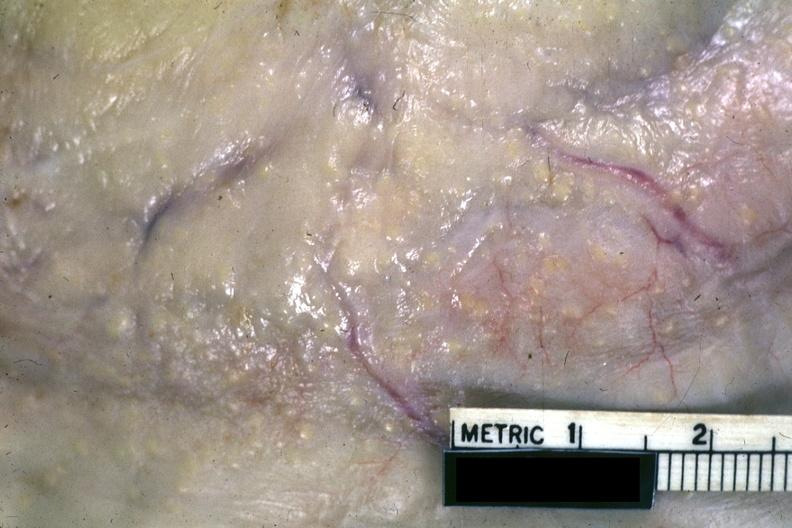s tuberculosis present?
Answer the question using a single word or phrase. No 